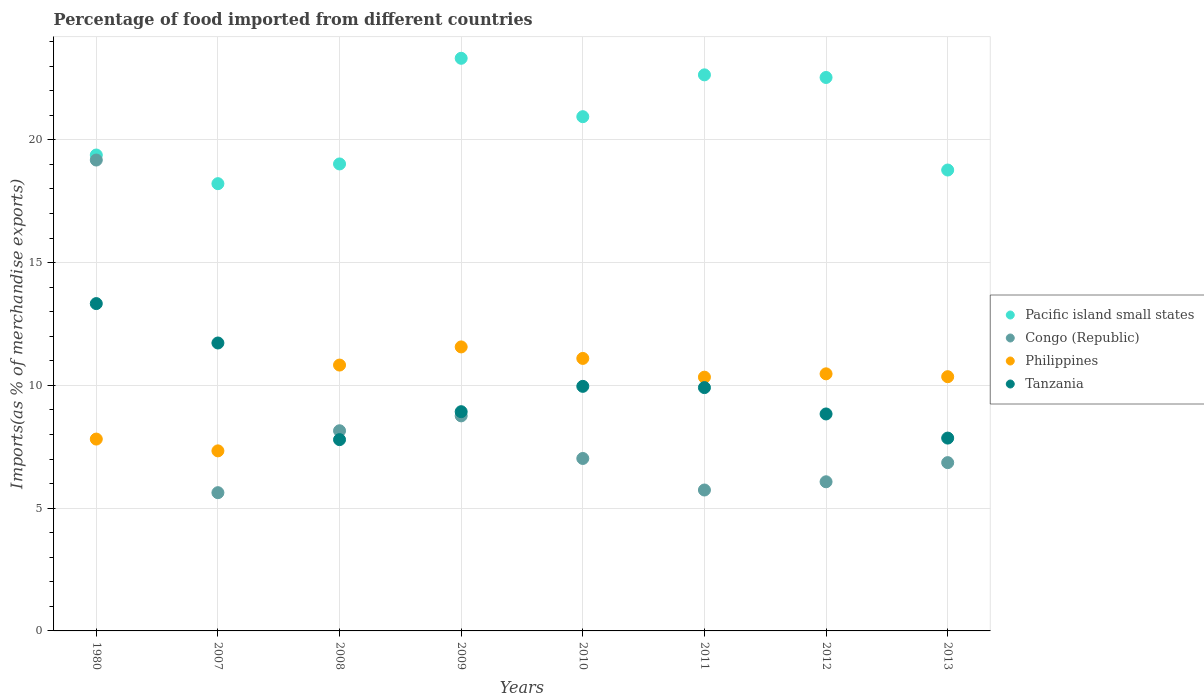How many different coloured dotlines are there?
Make the answer very short. 4. What is the percentage of imports to different countries in Congo (Republic) in 2010?
Make the answer very short. 7.02. Across all years, what is the maximum percentage of imports to different countries in Tanzania?
Ensure brevity in your answer.  13.33. Across all years, what is the minimum percentage of imports to different countries in Congo (Republic)?
Ensure brevity in your answer.  5.63. In which year was the percentage of imports to different countries in Congo (Republic) minimum?
Your response must be concise. 2007. What is the total percentage of imports to different countries in Congo (Republic) in the graph?
Provide a succinct answer. 67.41. What is the difference between the percentage of imports to different countries in Philippines in 2007 and that in 2013?
Your answer should be compact. -3.02. What is the difference between the percentage of imports to different countries in Philippines in 2009 and the percentage of imports to different countries in Tanzania in 2007?
Offer a terse response. -0.16. What is the average percentage of imports to different countries in Philippines per year?
Provide a short and direct response. 9.98. In the year 2013, what is the difference between the percentage of imports to different countries in Philippines and percentage of imports to different countries in Congo (Republic)?
Offer a terse response. 3.5. In how many years, is the percentage of imports to different countries in Tanzania greater than 16 %?
Your response must be concise. 0. What is the ratio of the percentage of imports to different countries in Pacific island small states in 2007 to that in 2011?
Make the answer very short. 0.8. Is the percentage of imports to different countries in Congo (Republic) in 2010 less than that in 2013?
Provide a short and direct response. No. Is the difference between the percentage of imports to different countries in Philippines in 2007 and 2013 greater than the difference between the percentage of imports to different countries in Congo (Republic) in 2007 and 2013?
Provide a short and direct response. No. What is the difference between the highest and the second highest percentage of imports to different countries in Philippines?
Your answer should be compact. 0.47. What is the difference between the highest and the lowest percentage of imports to different countries in Philippines?
Your answer should be very brief. 4.23. Is the percentage of imports to different countries in Pacific island small states strictly greater than the percentage of imports to different countries in Tanzania over the years?
Keep it short and to the point. Yes. How many dotlines are there?
Offer a very short reply. 4. Where does the legend appear in the graph?
Offer a terse response. Center right. How many legend labels are there?
Your answer should be very brief. 4. How are the legend labels stacked?
Provide a short and direct response. Vertical. What is the title of the graph?
Offer a terse response. Percentage of food imported from different countries. What is the label or title of the X-axis?
Your answer should be very brief. Years. What is the label or title of the Y-axis?
Make the answer very short. Imports(as % of merchandise exports). What is the Imports(as % of merchandise exports) in Pacific island small states in 1980?
Keep it short and to the point. 19.38. What is the Imports(as % of merchandise exports) of Congo (Republic) in 1980?
Your answer should be compact. 19.18. What is the Imports(as % of merchandise exports) in Philippines in 1980?
Keep it short and to the point. 7.81. What is the Imports(as % of merchandise exports) in Tanzania in 1980?
Make the answer very short. 13.33. What is the Imports(as % of merchandise exports) in Pacific island small states in 2007?
Provide a succinct answer. 18.22. What is the Imports(as % of merchandise exports) in Congo (Republic) in 2007?
Keep it short and to the point. 5.63. What is the Imports(as % of merchandise exports) of Philippines in 2007?
Provide a short and direct response. 7.33. What is the Imports(as % of merchandise exports) of Tanzania in 2007?
Provide a short and direct response. 11.73. What is the Imports(as % of merchandise exports) in Pacific island small states in 2008?
Ensure brevity in your answer.  19.02. What is the Imports(as % of merchandise exports) of Congo (Republic) in 2008?
Provide a succinct answer. 8.15. What is the Imports(as % of merchandise exports) of Philippines in 2008?
Ensure brevity in your answer.  10.83. What is the Imports(as % of merchandise exports) in Tanzania in 2008?
Keep it short and to the point. 7.79. What is the Imports(as % of merchandise exports) in Pacific island small states in 2009?
Your answer should be very brief. 23.32. What is the Imports(as % of merchandise exports) of Congo (Republic) in 2009?
Ensure brevity in your answer.  8.76. What is the Imports(as % of merchandise exports) of Philippines in 2009?
Offer a terse response. 11.57. What is the Imports(as % of merchandise exports) in Tanzania in 2009?
Provide a short and direct response. 8.93. What is the Imports(as % of merchandise exports) in Pacific island small states in 2010?
Your answer should be very brief. 20.94. What is the Imports(as % of merchandise exports) of Congo (Republic) in 2010?
Offer a very short reply. 7.02. What is the Imports(as % of merchandise exports) in Philippines in 2010?
Your response must be concise. 11.1. What is the Imports(as % of merchandise exports) of Tanzania in 2010?
Give a very brief answer. 9.96. What is the Imports(as % of merchandise exports) of Pacific island small states in 2011?
Provide a short and direct response. 22.65. What is the Imports(as % of merchandise exports) of Congo (Republic) in 2011?
Your response must be concise. 5.74. What is the Imports(as % of merchandise exports) of Philippines in 2011?
Make the answer very short. 10.33. What is the Imports(as % of merchandise exports) in Tanzania in 2011?
Keep it short and to the point. 9.91. What is the Imports(as % of merchandise exports) of Pacific island small states in 2012?
Your response must be concise. 22.54. What is the Imports(as % of merchandise exports) in Congo (Republic) in 2012?
Ensure brevity in your answer.  6.07. What is the Imports(as % of merchandise exports) in Philippines in 2012?
Your response must be concise. 10.47. What is the Imports(as % of merchandise exports) of Tanzania in 2012?
Your response must be concise. 8.84. What is the Imports(as % of merchandise exports) of Pacific island small states in 2013?
Give a very brief answer. 18.77. What is the Imports(as % of merchandise exports) of Congo (Republic) in 2013?
Ensure brevity in your answer.  6.85. What is the Imports(as % of merchandise exports) in Philippines in 2013?
Provide a succinct answer. 10.35. What is the Imports(as % of merchandise exports) of Tanzania in 2013?
Ensure brevity in your answer.  7.85. Across all years, what is the maximum Imports(as % of merchandise exports) in Pacific island small states?
Your answer should be very brief. 23.32. Across all years, what is the maximum Imports(as % of merchandise exports) of Congo (Republic)?
Your answer should be very brief. 19.18. Across all years, what is the maximum Imports(as % of merchandise exports) of Philippines?
Provide a succinct answer. 11.57. Across all years, what is the maximum Imports(as % of merchandise exports) of Tanzania?
Provide a short and direct response. 13.33. Across all years, what is the minimum Imports(as % of merchandise exports) in Pacific island small states?
Keep it short and to the point. 18.22. Across all years, what is the minimum Imports(as % of merchandise exports) of Congo (Republic)?
Give a very brief answer. 5.63. Across all years, what is the minimum Imports(as % of merchandise exports) of Philippines?
Your answer should be very brief. 7.33. Across all years, what is the minimum Imports(as % of merchandise exports) of Tanzania?
Keep it short and to the point. 7.79. What is the total Imports(as % of merchandise exports) in Pacific island small states in the graph?
Give a very brief answer. 164.84. What is the total Imports(as % of merchandise exports) in Congo (Republic) in the graph?
Give a very brief answer. 67.41. What is the total Imports(as % of merchandise exports) of Philippines in the graph?
Your response must be concise. 79.8. What is the total Imports(as % of merchandise exports) of Tanzania in the graph?
Provide a succinct answer. 78.34. What is the difference between the Imports(as % of merchandise exports) in Pacific island small states in 1980 and that in 2007?
Provide a short and direct response. 1.17. What is the difference between the Imports(as % of merchandise exports) in Congo (Republic) in 1980 and that in 2007?
Provide a short and direct response. 13.55. What is the difference between the Imports(as % of merchandise exports) of Philippines in 1980 and that in 2007?
Your answer should be compact. 0.48. What is the difference between the Imports(as % of merchandise exports) in Tanzania in 1980 and that in 2007?
Your answer should be compact. 1.6. What is the difference between the Imports(as % of merchandise exports) of Pacific island small states in 1980 and that in 2008?
Offer a terse response. 0.36. What is the difference between the Imports(as % of merchandise exports) of Congo (Republic) in 1980 and that in 2008?
Provide a short and direct response. 11.03. What is the difference between the Imports(as % of merchandise exports) in Philippines in 1980 and that in 2008?
Give a very brief answer. -3.01. What is the difference between the Imports(as % of merchandise exports) in Tanzania in 1980 and that in 2008?
Provide a succinct answer. 5.54. What is the difference between the Imports(as % of merchandise exports) in Pacific island small states in 1980 and that in 2009?
Your response must be concise. -3.94. What is the difference between the Imports(as % of merchandise exports) of Congo (Republic) in 1980 and that in 2009?
Ensure brevity in your answer.  10.42. What is the difference between the Imports(as % of merchandise exports) in Philippines in 1980 and that in 2009?
Ensure brevity in your answer.  -3.75. What is the difference between the Imports(as % of merchandise exports) in Tanzania in 1980 and that in 2009?
Offer a very short reply. 4.4. What is the difference between the Imports(as % of merchandise exports) of Pacific island small states in 1980 and that in 2010?
Provide a short and direct response. -1.56. What is the difference between the Imports(as % of merchandise exports) in Congo (Republic) in 1980 and that in 2010?
Your answer should be compact. 12.15. What is the difference between the Imports(as % of merchandise exports) in Philippines in 1980 and that in 2010?
Make the answer very short. -3.28. What is the difference between the Imports(as % of merchandise exports) in Tanzania in 1980 and that in 2010?
Make the answer very short. 3.37. What is the difference between the Imports(as % of merchandise exports) in Pacific island small states in 1980 and that in 2011?
Provide a succinct answer. -3.26. What is the difference between the Imports(as % of merchandise exports) in Congo (Republic) in 1980 and that in 2011?
Your answer should be very brief. 13.44. What is the difference between the Imports(as % of merchandise exports) of Philippines in 1980 and that in 2011?
Ensure brevity in your answer.  -2.52. What is the difference between the Imports(as % of merchandise exports) in Tanzania in 1980 and that in 2011?
Provide a short and direct response. 3.42. What is the difference between the Imports(as % of merchandise exports) of Pacific island small states in 1980 and that in 2012?
Provide a short and direct response. -3.16. What is the difference between the Imports(as % of merchandise exports) in Congo (Republic) in 1980 and that in 2012?
Offer a very short reply. 13.1. What is the difference between the Imports(as % of merchandise exports) of Philippines in 1980 and that in 2012?
Provide a succinct answer. -2.66. What is the difference between the Imports(as % of merchandise exports) of Tanzania in 1980 and that in 2012?
Ensure brevity in your answer.  4.49. What is the difference between the Imports(as % of merchandise exports) of Pacific island small states in 1980 and that in 2013?
Make the answer very short. 0.61. What is the difference between the Imports(as % of merchandise exports) in Congo (Republic) in 1980 and that in 2013?
Provide a short and direct response. 12.32. What is the difference between the Imports(as % of merchandise exports) of Philippines in 1980 and that in 2013?
Provide a succinct answer. -2.54. What is the difference between the Imports(as % of merchandise exports) of Tanzania in 1980 and that in 2013?
Provide a succinct answer. 5.48. What is the difference between the Imports(as % of merchandise exports) of Pacific island small states in 2007 and that in 2008?
Your response must be concise. -0.8. What is the difference between the Imports(as % of merchandise exports) of Congo (Republic) in 2007 and that in 2008?
Keep it short and to the point. -2.52. What is the difference between the Imports(as % of merchandise exports) in Philippines in 2007 and that in 2008?
Your answer should be compact. -3.49. What is the difference between the Imports(as % of merchandise exports) in Tanzania in 2007 and that in 2008?
Make the answer very short. 3.94. What is the difference between the Imports(as % of merchandise exports) in Pacific island small states in 2007 and that in 2009?
Make the answer very short. -5.11. What is the difference between the Imports(as % of merchandise exports) in Congo (Republic) in 2007 and that in 2009?
Provide a short and direct response. -3.13. What is the difference between the Imports(as % of merchandise exports) of Philippines in 2007 and that in 2009?
Provide a succinct answer. -4.23. What is the difference between the Imports(as % of merchandise exports) in Tanzania in 2007 and that in 2009?
Give a very brief answer. 2.8. What is the difference between the Imports(as % of merchandise exports) of Pacific island small states in 2007 and that in 2010?
Your answer should be compact. -2.73. What is the difference between the Imports(as % of merchandise exports) in Congo (Republic) in 2007 and that in 2010?
Offer a very short reply. -1.39. What is the difference between the Imports(as % of merchandise exports) of Philippines in 2007 and that in 2010?
Your response must be concise. -3.77. What is the difference between the Imports(as % of merchandise exports) of Tanzania in 2007 and that in 2010?
Keep it short and to the point. 1.77. What is the difference between the Imports(as % of merchandise exports) in Pacific island small states in 2007 and that in 2011?
Make the answer very short. -4.43. What is the difference between the Imports(as % of merchandise exports) of Congo (Republic) in 2007 and that in 2011?
Ensure brevity in your answer.  -0.11. What is the difference between the Imports(as % of merchandise exports) of Philippines in 2007 and that in 2011?
Your answer should be very brief. -3. What is the difference between the Imports(as % of merchandise exports) of Tanzania in 2007 and that in 2011?
Your answer should be very brief. 1.82. What is the difference between the Imports(as % of merchandise exports) in Pacific island small states in 2007 and that in 2012?
Offer a terse response. -4.33. What is the difference between the Imports(as % of merchandise exports) in Congo (Republic) in 2007 and that in 2012?
Offer a very short reply. -0.44. What is the difference between the Imports(as % of merchandise exports) of Philippines in 2007 and that in 2012?
Keep it short and to the point. -3.14. What is the difference between the Imports(as % of merchandise exports) of Tanzania in 2007 and that in 2012?
Provide a succinct answer. 2.89. What is the difference between the Imports(as % of merchandise exports) of Pacific island small states in 2007 and that in 2013?
Your response must be concise. -0.56. What is the difference between the Imports(as % of merchandise exports) in Congo (Republic) in 2007 and that in 2013?
Offer a terse response. -1.22. What is the difference between the Imports(as % of merchandise exports) of Philippines in 2007 and that in 2013?
Make the answer very short. -3.02. What is the difference between the Imports(as % of merchandise exports) in Tanzania in 2007 and that in 2013?
Provide a short and direct response. 3.87. What is the difference between the Imports(as % of merchandise exports) of Pacific island small states in 2008 and that in 2009?
Make the answer very short. -4.3. What is the difference between the Imports(as % of merchandise exports) of Congo (Republic) in 2008 and that in 2009?
Your answer should be compact. -0.61. What is the difference between the Imports(as % of merchandise exports) of Philippines in 2008 and that in 2009?
Your answer should be very brief. -0.74. What is the difference between the Imports(as % of merchandise exports) of Tanzania in 2008 and that in 2009?
Provide a succinct answer. -1.14. What is the difference between the Imports(as % of merchandise exports) of Pacific island small states in 2008 and that in 2010?
Provide a short and direct response. -1.92. What is the difference between the Imports(as % of merchandise exports) in Congo (Republic) in 2008 and that in 2010?
Ensure brevity in your answer.  1.13. What is the difference between the Imports(as % of merchandise exports) of Philippines in 2008 and that in 2010?
Offer a terse response. -0.27. What is the difference between the Imports(as % of merchandise exports) in Tanzania in 2008 and that in 2010?
Keep it short and to the point. -2.17. What is the difference between the Imports(as % of merchandise exports) of Pacific island small states in 2008 and that in 2011?
Offer a very short reply. -3.63. What is the difference between the Imports(as % of merchandise exports) of Congo (Republic) in 2008 and that in 2011?
Give a very brief answer. 2.41. What is the difference between the Imports(as % of merchandise exports) in Philippines in 2008 and that in 2011?
Your answer should be compact. 0.49. What is the difference between the Imports(as % of merchandise exports) in Tanzania in 2008 and that in 2011?
Offer a terse response. -2.12. What is the difference between the Imports(as % of merchandise exports) of Pacific island small states in 2008 and that in 2012?
Your answer should be very brief. -3.52. What is the difference between the Imports(as % of merchandise exports) of Congo (Republic) in 2008 and that in 2012?
Make the answer very short. 2.08. What is the difference between the Imports(as % of merchandise exports) of Philippines in 2008 and that in 2012?
Give a very brief answer. 0.36. What is the difference between the Imports(as % of merchandise exports) in Tanzania in 2008 and that in 2012?
Your answer should be compact. -1.05. What is the difference between the Imports(as % of merchandise exports) of Pacific island small states in 2008 and that in 2013?
Provide a succinct answer. 0.25. What is the difference between the Imports(as % of merchandise exports) in Congo (Republic) in 2008 and that in 2013?
Ensure brevity in your answer.  1.3. What is the difference between the Imports(as % of merchandise exports) of Philippines in 2008 and that in 2013?
Give a very brief answer. 0.47. What is the difference between the Imports(as % of merchandise exports) in Tanzania in 2008 and that in 2013?
Make the answer very short. -0.06. What is the difference between the Imports(as % of merchandise exports) in Pacific island small states in 2009 and that in 2010?
Provide a short and direct response. 2.38. What is the difference between the Imports(as % of merchandise exports) in Congo (Republic) in 2009 and that in 2010?
Your answer should be compact. 1.74. What is the difference between the Imports(as % of merchandise exports) of Philippines in 2009 and that in 2010?
Provide a short and direct response. 0.47. What is the difference between the Imports(as % of merchandise exports) of Tanzania in 2009 and that in 2010?
Provide a succinct answer. -1.03. What is the difference between the Imports(as % of merchandise exports) in Pacific island small states in 2009 and that in 2011?
Keep it short and to the point. 0.67. What is the difference between the Imports(as % of merchandise exports) of Congo (Republic) in 2009 and that in 2011?
Offer a very short reply. 3.02. What is the difference between the Imports(as % of merchandise exports) in Philippines in 2009 and that in 2011?
Your answer should be very brief. 1.23. What is the difference between the Imports(as % of merchandise exports) of Tanzania in 2009 and that in 2011?
Your answer should be compact. -0.98. What is the difference between the Imports(as % of merchandise exports) of Pacific island small states in 2009 and that in 2012?
Keep it short and to the point. 0.78. What is the difference between the Imports(as % of merchandise exports) of Congo (Republic) in 2009 and that in 2012?
Your answer should be compact. 2.68. What is the difference between the Imports(as % of merchandise exports) in Philippines in 2009 and that in 2012?
Give a very brief answer. 1.1. What is the difference between the Imports(as % of merchandise exports) in Tanzania in 2009 and that in 2012?
Keep it short and to the point. 0.09. What is the difference between the Imports(as % of merchandise exports) of Pacific island small states in 2009 and that in 2013?
Offer a terse response. 4.55. What is the difference between the Imports(as % of merchandise exports) of Congo (Republic) in 2009 and that in 2013?
Provide a succinct answer. 1.9. What is the difference between the Imports(as % of merchandise exports) in Philippines in 2009 and that in 2013?
Provide a short and direct response. 1.21. What is the difference between the Imports(as % of merchandise exports) of Tanzania in 2009 and that in 2013?
Your response must be concise. 1.08. What is the difference between the Imports(as % of merchandise exports) in Pacific island small states in 2010 and that in 2011?
Keep it short and to the point. -1.7. What is the difference between the Imports(as % of merchandise exports) of Congo (Republic) in 2010 and that in 2011?
Provide a short and direct response. 1.28. What is the difference between the Imports(as % of merchandise exports) of Philippines in 2010 and that in 2011?
Make the answer very short. 0.76. What is the difference between the Imports(as % of merchandise exports) of Tanzania in 2010 and that in 2011?
Your answer should be very brief. 0.05. What is the difference between the Imports(as % of merchandise exports) of Pacific island small states in 2010 and that in 2012?
Provide a succinct answer. -1.6. What is the difference between the Imports(as % of merchandise exports) in Congo (Republic) in 2010 and that in 2012?
Offer a terse response. 0.95. What is the difference between the Imports(as % of merchandise exports) in Philippines in 2010 and that in 2012?
Your answer should be compact. 0.63. What is the difference between the Imports(as % of merchandise exports) of Tanzania in 2010 and that in 2012?
Make the answer very short. 1.12. What is the difference between the Imports(as % of merchandise exports) in Pacific island small states in 2010 and that in 2013?
Your response must be concise. 2.17. What is the difference between the Imports(as % of merchandise exports) in Congo (Republic) in 2010 and that in 2013?
Ensure brevity in your answer.  0.17. What is the difference between the Imports(as % of merchandise exports) of Philippines in 2010 and that in 2013?
Ensure brevity in your answer.  0.74. What is the difference between the Imports(as % of merchandise exports) of Tanzania in 2010 and that in 2013?
Make the answer very short. 2.11. What is the difference between the Imports(as % of merchandise exports) in Pacific island small states in 2011 and that in 2012?
Make the answer very short. 0.11. What is the difference between the Imports(as % of merchandise exports) of Congo (Republic) in 2011 and that in 2012?
Make the answer very short. -0.34. What is the difference between the Imports(as % of merchandise exports) in Philippines in 2011 and that in 2012?
Your answer should be very brief. -0.14. What is the difference between the Imports(as % of merchandise exports) of Tanzania in 2011 and that in 2012?
Keep it short and to the point. 1.07. What is the difference between the Imports(as % of merchandise exports) of Pacific island small states in 2011 and that in 2013?
Ensure brevity in your answer.  3.88. What is the difference between the Imports(as % of merchandise exports) in Congo (Republic) in 2011 and that in 2013?
Your answer should be very brief. -1.11. What is the difference between the Imports(as % of merchandise exports) of Philippines in 2011 and that in 2013?
Ensure brevity in your answer.  -0.02. What is the difference between the Imports(as % of merchandise exports) in Tanzania in 2011 and that in 2013?
Provide a short and direct response. 2.06. What is the difference between the Imports(as % of merchandise exports) of Pacific island small states in 2012 and that in 2013?
Offer a very short reply. 3.77. What is the difference between the Imports(as % of merchandise exports) in Congo (Republic) in 2012 and that in 2013?
Your response must be concise. -0.78. What is the difference between the Imports(as % of merchandise exports) of Philippines in 2012 and that in 2013?
Offer a very short reply. 0.12. What is the difference between the Imports(as % of merchandise exports) of Tanzania in 2012 and that in 2013?
Your answer should be compact. 0.98. What is the difference between the Imports(as % of merchandise exports) of Pacific island small states in 1980 and the Imports(as % of merchandise exports) of Congo (Republic) in 2007?
Your answer should be compact. 13.75. What is the difference between the Imports(as % of merchandise exports) of Pacific island small states in 1980 and the Imports(as % of merchandise exports) of Philippines in 2007?
Make the answer very short. 12.05. What is the difference between the Imports(as % of merchandise exports) of Pacific island small states in 1980 and the Imports(as % of merchandise exports) of Tanzania in 2007?
Keep it short and to the point. 7.66. What is the difference between the Imports(as % of merchandise exports) of Congo (Republic) in 1980 and the Imports(as % of merchandise exports) of Philippines in 2007?
Give a very brief answer. 11.85. What is the difference between the Imports(as % of merchandise exports) of Congo (Republic) in 1980 and the Imports(as % of merchandise exports) of Tanzania in 2007?
Make the answer very short. 7.45. What is the difference between the Imports(as % of merchandise exports) of Philippines in 1980 and the Imports(as % of merchandise exports) of Tanzania in 2007?
Offer a terse response. -3.91. What is the difference between the Imports(as % of merchandise exports) of Pacific island small states in 1980 and the Imports(as % of merchandise exports) of Congo (Republic) in 2008?
Keep it short and to the point. 11.23. What is the difference between the Imports(as % of merchandise exports) of Pacific island small states in 1980 and the Imports(as % of merchandise exports) of Philippines in 2008?
Offer a very short reply. 8.56. What is the difference between the Imports(as % of merchandise exports) of Pacific island small states in 1980 and the Imports(as % of merchandise exports) of Tanzania in 2008?
Provide a short and direct response. 11.59. What is the difference between the Imports(as % of merchandise exports) of Congo (Republic) in 1980 and the Imports(as % of merchandise exports) of Philippines in 2008?
Provide a succinct answer. 8.35. What is the difference between the Imports(as % of merchandise exports) in Congo (Republic) in 1980 and the Imports(as % of merchandise exports) in Tanzania in 2008?
Keep it short and to the point. 11.39. What is the difference between the Imports(as % of merchandise exports) of Philippines in 1980 and the Imports(as % of merchandise exports) of Tanzania in 2008?
Your answer should be very brief. 0.02. What is the difference between the Imports(as % of merchandise exports) of Pacific island small states in 1980 and the Imports(as % of merchandise exports) of Congo (Republic) in 2009?
Provide a succinct answer. 10.62. What is the difference between the Imports(as % of merchandise exports) in Pacific island small states in 1980 and the Imports(as % of merchandise exports) in Philippines in 2009?
Make the answer very short. 7.82. What is the difference between the Imports(as % of merchandise exports) in Pacific island small states in 1980 and the Imports(as % of merchandise exports) in Tanzania in 2009?
Give a very brief answer. 10.45. What is the difference between the Imports(as % of merchandise exports) of Congo (Republic) in 1980 and the Imports(as % of merchandise exports) of Philippines in 2009?
Keep it short and to the point. 7.61. What is the difference between the Imports(as % of merchandise exports) in Congo (Republic) in 1980 and the Imports(as % of merchandise exports) in Tanzania in 2009?
Provide a short and direct response. 10.25. What is the difference between the Imports(as % of merchandise exports) in Philippines in 1980 and the Imports(as % of merchandise exports) in Tanzania in 2009?
Ensure brevity in your answer.  -1.12. What is the difference between the Imports(as % of merchandise exports) in Pacific island small states in 1980 and the Imports(as % of merchandise exports) in Congo (Republic) in 2010?
Keep it short and to the point. 12.36. What is the difference between the Imports(as % of merchandise exports) of Pacific island small states in 1980 and the Imports(as % of merchandise exports) of Philippines in 2010?
Give a very brief answer. 8.28. What is the difference between the Imports(as % of merchandise exports) in Pacific island small states in 1980 and the Imports(as % of merchandise exports) in Tanzania in 2010?
Provide a short and direct response. 9.42. What is the difference between the Imports(as % of merchandise exports) in Congo (Republic) in 1980 and the Imports(as % of merchandise exports) in Philippines in 2010?
Provide a short and direct response. 8.08. What is the difference between the Imports(as % of merchandise exports) in Congo (Republic) in 1980 and the Imports(as % of merchandise exports) in Tanzania in 2010?
Ensure brevity in your answer.  9.22. What is the difference between the Imports(as % of merchandise exports) in Philippines in 1980 and the Imports(as % of merchandise exports) in Tanzania in 2010?
Make the answer very short. -2.15. What is the difference between the Imports(as % of merchandise exports) of Pacific island small states in 1980 and the Imports(as % of merchandise exports) of Congo (Republic) in 2011?
Give a very brief answer. 13.64. What is the difference between the Imports(as % of merchandise exports) in Pacific island small states in 1980 and the Imports(as % of merchandise exports) in Philippines in 2011?
Keep it short and to the point. 9.05. What is the difference between the Imports(as % of merchandise exports) of Pacific island small states in 1980 and the Imports(as % of merchandise exports) of Tanzania in 2011?
Your answer should be very brief. 9.47. What is the difference between the Imports(as % of merchandise exports) of Congo (Republic) in 1980 and the Imports(as % of merchandise exports) of Philippines in 2011?
Provide a succinct answer. 8.84. What is the difference between the Imports(as % of merchandise exports) of Congo (Republic) in 1980 and the Imports(as % of merchandise exports) of Tanzania in 2011?
Provide a succinct answer. 9.27. What is the difference between the Imports(as % of merchandise exports) of Philippines in 1980 and the Imports(as % of merchandise exports) of Tanzania in 2011?
Your response must be concise. -2.1. What is the difference between the Imports(as % of merchandise exports) in Pacific island small states in 1980 and the Imports(as % of merchandise exports) in Congo (Republic) in 2012?
Provide a short and direct response. 13.31. What is the difference between the Imports(as % of merchandise exports) in Pacific island small states in 1980 and the Imports(as % of merchandise exports) in Philippines in 2012?
Make the answer very short. 8.91. What is the difference between the Imports(as % of merchandise exports) of Pacific island small states in 1980 and the Imports(as % of merchandise exports) of Tanzania in 2012?
Your answer should be compact. 10.55. What is the difference between the Imports(as % of merchandise exports) of Congo (Republic) in 1980 and the Imports(as % of merchandise exports) of Philippines in 2012?
Your response must be concise. 8.71. What is the difference between the Imports(as % of merchandise exports) in Congo (Republic) in 1980 and the Imports(as % of merchandise exports) in Tanzania in 2012?
Provide a short and direct response. 10.34. What is the difference between the Imports(as % of merchandise exports) of Philippines in 1980 and the Imports(as % of merchandise exports) of Tanzania in 2012?
Your answer should be very brief. -1.02. What is the difference between the Imports(as % of merchandise exports) of Pacific island small states in 1980 and the Imports(as % of merchandise exports) of Congo (Republic) in 2013?
Keep it short and to the point. 12.53. What is the difference between the Imports(as % of merchandise exports) in Pacific island small states in 1980 and the Imports(as % of merchandise exports) in Philippines in 2013?
Provide a short and direct response. 9.03. What is the difference between the Imports(as % of merchandise exports) in Pacific island small states in 1980 and the Imports(as % of merchandise exports) in Tanzania in 2013?
Your response must be concise. 11.53. What is the difference between the Imports(as % of merchandise exports) in Congo (Republic) in 1980 and the Imports(as % of merchandise exports) in Philippines in 2013?
Ensure brevity in your answer.  8.82. What is the difference between the Imports(as % of merchandise exports) of Congo (Republic) in 1980 and the Imports(as % of merchandise exports) of Tanzania in 2013?
Ensure brevity in your answer.  11.32. What is the difference between the Imports(as % of merchandise exports) in Philippines in 1980 and the Imports(as % of merchandise exports) in Tanzania in 2013?
Give a very brief answer. -0.04. What is the difference between the Imports(as % of merchandise exports) in Pacific island small states in 2007 and the Imports(as % of merchandise exports) in Congo (Republic) in 2008?
Keep it short and to the point. 10.06. What is the difference between the Imports(as % of merchandise exports) of Pacific island small states in 2007 and the Imports(as % of merchandise exports) of Philippines in 2008?
Provide a short and direct response. 7.39. What is the difference between the Imports(as % of merchandise exports) of Pacific island small states in 2007 and the Imports(as % of merchandise exports) of Tanzania in 2008?
Your answer should be compact. 10.43. What is the difference between the Imports(as % of merchandise exports) of Congo (Republic) in 2007 and the Imports(as % of merchandise exports) of Philippines in 2008?
Make the answer very short. -5.2. What is the difference between the Imports(as % of merchandise exports) in Congo (Republic) in 2007 and the Imports(as % of merchandise exports) in Tanzania in 2008?
Your response must be concise. -2.16. What is the difference between the Imports(as % of merchandise exports) of Philippines in 2007 and the Imports(as % of merchandise exports) of Tanzania in 2008?
Offer a terse response. -0.46. What is the difference between the Imports(as % of merchandise exports) in Pacific island small states in 2007 and the Imports(as % of merchandise exports) in Congo (Republic) in 2009?
Make the answer very short. 9.46. What is the difference between the Imports(as % of merchandise exports) in Pacific island small states in 2007 and the Imports(as % of merchandise exports) in Philippines in 2009?
Your response must be concise. 6.65. What is the difference between the Imports(as % of merchandise exports) in Pacific island small states in 2007 and the Imports(as % of merchandise exports) in Tanzania in 2009?
Ensure brevity in your answer.  9.29. What is the difference between the Imports(as % of merchandise exports) in Congo (Republic) in 2007 and the Imports(as % of merchandise exports) in Philippines in 2009?
Your response must be concise. -5.94. What is the difference between the Imports(as % of merchandise exports) in Congo (Republic) in 2007 and the Imports(as % of merchandise exports) in Tanzania in 2009?
Make the answer very short. -3.3. What is the difference between the Imports(as % of merchandise exports) in Philippines in 2007 and the Imports(as % of merchandise exports) in Tanzania in 2009?
Give a very brief answer. -1.6. What is the difference between the Imports(as % of merchandise exports) of Pacific island small states in 2007 and the Imports(as % of merchandise exports) of Congo (Republic) in 2010?
Provide a short and direct response. 11.19. What is the difference between the Imports(as % of merchandise exports) of Pacific island small states in 2007 and the Imports(as % of merchandise exports) of Philippines in 2010?
Give a very brief answer. 7.12. What is the difference between the Imports(as % of merchandise exports) in Pacific island small states in 2007 and the Imports(as % of merchandise exports) in Tanzania in 2010?
Ensure brevity in your answer.  8.25. What is the difference between the Imports(as % of merchandise exports) of Congo (Republic) in 2007 and the Imports(as % of merchandise exports) of Philippines in 2010?
Your answer should be compact. -5.47. What is the difference between the Imports(as % of merchandise exports) in Congo (Republic) in 2007 and the Imports(as % of merchandise exports) in Tanzania in 2010?
Your response must be concise. -4.33. What is the difference between the Imports(as % of merchandise exports) of Philippines in 2007 and the Imports(as % of merchandise exports) of Tanzania in 2010?
Provide a succinct answer. -2.63. What is the difference between the Imports(as % of merchandise exports) of Pacific island small states in 2007 and the Imports(as % of merchandise exports) of Congo (Republic) in 2011?
Your answer should be compact. 12.48. What is the difference between the Imports(as % of merchandise exports) of Pacific island small states in 2007 and the Imports(as % of merchandise exports) of Philippines in 2011?
Offer a terse response. 7.88. What is the difference between the Imports(as % of merchandise exports) in Pacific island small states in 2007 and the Imports(as % of merchandise exports) in Tanzania in 2011?
Ensure brevity in your answer.  8.31. What is the difference between the Imports(as % of merchandise exports) of Congo (Republic) in 2007 and the Imports(as % of merchandise exports) of Philippines in 2011?
Your answer should be compact. -4.7. What is the difference between the Imports(as % of merchandise exports) of Congo (Republic) in 2007 and the Imports(as % of merchandise exports) of Tanzania in 2011?
Offer a very short reply. -4.28. What is the difference between the Imports(as % of merchandise exports) in Philippines in 2007 and the Imports(as % of merchandise exports) in Tanzania in 2011?
Provide a short and direct response. -2.58. What is the difference between the Imports(as % of merchandise exports) in Pacific island small states in 2007 and the Imports(as % of merchandise exports) in Congo (Republic) in 2012?
Keep it short and to the point. 12.14. What is the difference between the Imports(as % of merchandise exports) in Pacific island small states in 2007 and the Imports(as % of merchandise exports) in Philippines in 2012?
Give a very brief answer. 7.75. What is the difference between the Imports(as % of merchandise exports) of Pacific island small states in 2007 and the Imports(as % of merchandise exports) of Tanzania in 2012?
Provide a succinct answer. 9.38. What is the difference between the Imports(as % of merchandise exports) of Congo (Republic) in 2007 and the Imports(as % of merchandise exports) of Philippines in 2012?
Give a very brief answer. -4.84. What is the difference between the Imports(as % of merchandise exports) of Congo (Republic) in 2007 and the Imports(as % of merchandise exports) of Tanzania in 2012?
Make the answer very short. -3.21. What is the difference between the Imports(as % of merchandise exports) of Philippines in 2007 and the Imports(as % of merchandise exports) of Tanzania in 2012?
Your response must be concise. -1.5. What is the difference between the Imports(as % of merchandise exports) in Pacific island small states in 2007 and the Imports(as % of merchandise exports) in Congo (Republic) in 2013?
Keep it short and to the point. 11.36. What is the difference between the Imports(as % of merchandise exports) in Pacific island small states in 2007 and the Imports(as % of merchandise exports) in Philippines in 2013?
Ensure brevity in your answer.  7.86. What is the difference between the Imports(as % of merchandise exports) of Pacific island small states in 2007 and the Imports(as % of merchandise exports) of Tanzania in 2013?
Ensure brevity in your answer.  10.36. What is the difference between the Imports(as % of merchandise exports) of Congo (Republic) in 2007 and the Imports(as % of merchandise exports) of Philippines in 2013?
Your response must be concise. -4.72. What is the difference between the Imports(as % of merchandise exports) in Congo (Republic) in 2007 and the Imports(as % of merchandise exports) in Tanzania in 2013?
Offer a very short reply. -2.22. What is the difference between the Imports(as % of merchandise exports) in Philippines in 2007 and the Imports(as % of merchandise exports) in Tanzania in 2013?
Ensure brevity in your answer.  -0.52. What is the difference between the Imports(as % of merchandise exports) of Pacific island small states in 2008 and the Imports(as % of merchandise exports) of Congo (Republic) in 2009?
Ensure brevity in your answer.  10.26. What is the difference between the Imports(as % of merchandise exports) in Pacific island small states in 2008 and the Imports(as % of merchandise exports) in Philippines in 2009?
Keep it short and to the point. 7.45. What is the difference between the Imports(as % of merchandise exports) in Pacific island small states in 2008 and the Imports(as % of merchandise exports) in Tanzania in 2009?
Your answer should be very brief. 10.09. What is the difference between the Imports(as % of merchandise exports) of Congo (Republic) in 2008 and the Imports(as % of merchandise exports) of Philippines in 2009?
Your answer should be compact. -3.41. What is the difference between the Imports(as % of merchandise exports) in Congo (Republic) in 2008 and the Imports(as % of merchandise exports) in Tanzania in 2009?
Ensure brevity in your answer.  -0.78. What is the difference between the Imports(as % of merchandise exports) of Philippines in 2008 and the Imports(as % of merchandise exports) of Tanzania in 2009?
Make the answer very short. 1.9. What is the difference between the Imports(as % of merchandise exports) of Pacific island small states in 2008 and the Imports(as % of merchandise exports) of Congo (Republic) in 2010?
Make the answer very short. 12. What is the difference between the Imports(as % of merchandise exports) of Pacific island small states in 2008 and the Imports(as % of merchandise exports) of Philippines in 2010?
Keep it short and to the point. 7.92. What is the difference between the Imports(as % of merchandise exports) of Pacific island small states in 2008 and the Imports(as % of merchandise exports) of Tanzania in 2010?
Give a very brief answer. 9.06. What is the difference between the Imports(as % of merchandise exports) in Congo (Republic) in 2008 and the Imports(as % of merchandise exports) in Philippines in 2010?
Make the answer very short. -2.95. What is the difference between the Imports(as % of merchandise exports) in Congo (Republic) in 2008 and the Imports(as % of merchandise exports) in Tanzania in 2010?
Provide a short and direct response. -1.81. What is the difference between the Imports(as % of merchandise exports) in Philippines in 2008 and the Imports(as % of merchandise exports) in Tanzania in 2010?
Your answer should be compact. 0.87. What is the difference between the Imports(as % of merchandise exports) in Pacific island small states in 2008 and the Imports(as % of merchandise exports) in Congo (Republic) in 2011?
Offer a very short reply. 13.28. What is the difference between the Imports(as % of merchandise exports) in Pacific island small states in 2008 and the Imports(as % of merchandise exports) in Philippines in 2011?
Your answer should be compact. 8.68. What is the difference between the Imports(as % of merchandise exports) in Pacific island small states in 2008 and the Imports(as % of merchandise exports) in Tanzania in 2011?
Keep it short and to the point. 9.11. What is the difference between the Imports(as % of merchandise exports) of Congo (Republic) in 2008 and the Imports(as % of merchandise exports) of Philippines in 2011?
Offer a very short reply. -2.18. What is the difference between the Imports(as % of merchandise exports) of Congo (Republic) in 2008 and the Imports(as % of merchandise exports) of Tanzania in 2011?
Keep it short and to the point. -1.76. What is the difference between the Imports(as % of merchandise exports) in Philippines in 2008 and the Imports(as % of merchandise exports) in Tanzania in 2011?
Offer a terse response. 0.92. What is the difference between the Imports(as % of merchandise exports) in Pacific island small states in 2008 and the Imports(as % of merchandise exports) in Congo (Republic) in 2012?
Ensure brevity in your answer.  12.94. What is the difference between the Imports(as % of merchandise exports) of Pacific island small states in 2008 and the Imports(as % of merchandise exports) of Philippines in 2012?
Offer a very short reply. 8.55. What is the difference between the Imports(as % of merchandise exports) in Pacific island small states in 2008 and the Imports(as % of merchandise exports) in Tanzania in 2012?
Provide a short and direct response. 10.18. What is the difference between the Imports(as % of merchandise exports) of Congo (Republic) in 2008 and the Imports(as % of merchandise exports) of Philippines in 2012?
Provide a succinct answer. -2.32. What is the difference between the Imports(as % of merchandise exports) in Congo (Republic) in 2008 and the Imports(as % of merchandise exports) in Tanzania in 2012?
Provide a short and direct response. -0.68. What is the difference between the Imports(as % of merchandise exports) of Philippines in 2008 and the Imports(as % of merchandise exports) of Tanzania in 2012?
Keep it short and to the point. 1.99. What is the difference between the Imports(as % of merchandise exports) in Pacific island small states in 2008 and the Imports(as % of merchandise exports) in Congo (Republic) in 2013?
Provide a succinct answer. 12.16. What is the difference between the Imports(as % of merchandise exports) of Pacific island small states in 2008 and the Imports(as % of merchandise exports) of Philippines in 2013?
Provide a short and direct response. 8.67. What is the difference between the Imports(as % of merchandise exports) in Pacific island small states in 2008 and the Imports(as % of merchandise exports) in Tanzania in 2013?
Offer a very short reply. 11.17. What is the difference between the Imports(as % of merchandise exports) of Congo (Republic) in 2008 and the Imports(as % of merchandise exports) of Philippines in 2013?
Ensure brevity in your answer.  -2.2. What is the difference between the Imports(as % of merchandise exports) in Congo (Republic) in 2008 and the Imports(as % of merchandise exports) in Tanzania in 2013?
Ensure brevity in your answer.  0.3. What is the difference between the Imports(as % of merchandise exports) in Philippines in 2008 and the Imports(as % of merchandise exports) in Tanzania in 2013?
Offer a terse response. 2.97. What is the difference between the Imports(as % of merchandise exports) of Pacific island small states in 2009 and the Imports(as % of merchandise exports) of Congo (Republic) in 2010?
Your response must be concise. 16.3. What is the difference between the Imports(as % of merchandise exports) of Pacific island small states in 2009 and the Imports(as % of merchandise exports) of Philippines in 2010?
Your response must be concise. 12.22. What is the difference between the Imports(as % of merchandise exports) in Pacific island small states in 2009 and the Imports(as % of merchandise exports) in Tanzania in 2010?
Offer a terse response. 13.36. What is the difference between the Imports(as % of merchandise exports) of Congo (Republic) in 2009 and the Imports(as % of merchandise exports) of Philippines in 2010?
Your answer should be very brief. -2.34. What is the difference between the Imports(as % of merchandise exports) in Congo (Republic) in 2009 and the Imports(as % of merchandise exports) in Tanzania in 2010?
Offer a very short reply. -1.2. What is the difference between the Imports(as % of merchandise exports) in Philippines in 2009 and the Imports(as % of merchandise exports) in Tanzania in 2010?
Make the answer very short. 1.61. What is the difference between the Imports(as % of merchandise exports) in Pacific island small states in 2009 and the Imports(as % of merchandise exports) in Congo (Republic) in 2011?
Your answer should be very brief. 17.58. What is the difference between the Imports(as % of merchandise exports) in Pacific island small states in 2009 and the Imports(as % of merchandise exports) in Philippines in 2011?
Keep it short and to the point. 12.99. What is the difference between the Imports(as % of merchandise exports) of Pacific island small states in 2009 and the Imports(as % of merchandise exports) of Tanzania in 2011?
Your answer should be very brief. 13.41. What is the difference between the Imports(as % of merchandise exports) of Congo (Republic) in 2009 and the Imports(as % of merchandise exports) of Philippines in 2011?
Provide a short and direct response. -1.58. What is the difference between the Imports(as % of merchandise exports) of Congo (Republic) in 2009 and the Imports(as % of merchandise exports) of Tanzania in 2011?
Your answer should be compact. -1.15. What is the difference between the Imports(as % of merchandise exports) in Philippines in 2009 and the Imports(as % of merchandise exports) in Tanzania in 2011?
Offer a very short reply. 1.66. What is the difference between the Imports(as % of merchandise exports) of Pacific island small states in 2009 and the Imports(as % of merchandise exports) of Congo (Republic) in 2012?
Your response must be concise. 17.25. What is the difference between the Imports(as % of merchandise exports) in Pacific island small states in 2009 and the Imports(as % of merchandise exports) in Philippines in 2012?
Make the answer very short. 12.85. What is the difference between the Imports(as % of merchandise exports) of Pacific island small states in 2009 and the Imports(as % of merchandise exports) of Tanzania in 2012?
Offer a very short reply. 14.49. What is the difference between the Imports(as % of merchandise exports) of Congo (Republic) in 2009 and the Imports(as % of merchandise exports) of Philippines in 2012?
Provide a short and direct response. -1.71. What is the difference between the Imports(as % of merchandise exports) of Congo (Republic) in 2009 and the Imports(as % of merchandise exports) of Tanzania in 2012?
Offer a very short reply. -0.08. What is the difference between the Imports(as % of merchandise exports) of Philippines in 2009 and the Imports(as % of merchandise exports) of Tanzania in 2012?
Make the answer very short. 2.73. What is the difference between the Imports(as % of merchandise exports) of Pacific island small states in 2009 and the Imports(as % of merchandise exports) of Congo (Republic) in 2013?
Offer a terse response. 16.47. What is the difference between the Imports(as % of merchandise exports) of Pacific island small states in 2009 and the Imports(as % of merchandise exports) of Philippines in 2013?
Your response must be concise. 12.97. What is the difference between the Imports(as % of merchandise exports) in Pacific island small states in 2009 and the Imports(as % of merchandise exports) in Tanzania in 2013?
Offer a very short reply. 15.47. What is the difference between the Imports(as % of merchandise exports) in Congo (Republic) in 2009 and the Imports(as % of merchandise exports) in Philippines in 2013?
Your response must be concise. -1.6. What is the difference between the Imports(as % of merchandise exports) in Congo (Republic) in 2009 and the Imports(as % of merchandise exports) in Tanzania in 2013?
Offer a terse response. 0.9. What is the difference between the Imports(as % of merchandise exports) in Philippines in 2009 and the Imports(as % of merchandise exports) in Tanzania in 2013?
Ensure brevity in your answer.  3.71. What is the difference between the Imports(as % of merchandise exports) of Pacific island small states in 2010 and the Imports(as % of merchandise exports) of Congo (Republic) in 2011?
Keep it short and to the point. 15.2. What is the difference between the Imports(as % of merchandise exports) of Pacific island small states in 2010 and the Imports(as % of merchandise exports) of Philippines in 2011?
Keep it short and to the point. 10.61. What is the difference between the Imports(as % of merchandise exports) of Pacific island small states in 2010 and the Imports(as % of merchandise exports) of Tanzania in 2011?
Provide a short and direct response. 11.03. What is the difference between the Imports(as % of merchandise exports) of Congo (Republic) in 2010 and the Imports(as % of merchandise exports) of Philippines in 2011?
Your answer should be compact. -3.31. What is the difference between the Imports(as % of merchandise exports) of Congo (Republic) in 2010 and the Imports(as % of merchandise exports) of Tanzania in 2011?
Your answer should be very brief. -2.89. What is the difference between the Imports(as % of merchandise exports) in Philippines in 2010 and the Imports(as % of merchandise exports) in Tanzania in 2011?
Make the answer very short. 1.19. What is the difference between the Imports(as % of merchandise exports) in Pacific island small states in 2010 and the Imports(as % of merchandise exports) in Congo (Republic) in 2012?
Your answer should be very brief. 14.87. What is the difference between the Imports(as % of merchandise exports) of Pacific island small states in 2010 and the Imports(as % of merchandise exports) of Philippines in 2012?
Provide a succinct answer. 10.47. What is the difference between the Imports(as % of merchandise exports) in Pacific island small states in 2010 and the Imports(as % of merchandise exports) in Tanzania in 2012?
Offer a very short reply. 12.11. What is the difference between the Imports(as % of merchandise exports) of Congo (Republic) in 2010 and the Imports(as % of merchandise exports) of Philippines in 2012?
Offer a terse response. -3.45. What is the difference between the Imports(as % of merchandise exports) of Congo (Republic) in 2010 and the Imports(as % of merchandise exports) of Tanzania in 2012?
Provide a short and direct response. -1.81. What is the difference between the Imports(as % of merchandise exports) of Philippines in 2010 and the Imports(as % of merchandise exports) of Tanzania in 2012?
Provide a short and direct response. 2.26. What is the difference between the Imports(as % of merchandise exports) of Pacific island small states in 2010 and the Imports(as % of merchandise exports) of Congo (Republic) in 2013?
Offer a terse response. 14.09. What is the difference between the Imports(as % of merchandise exports) in Pacific island small states in 2010 and the Imports(as % of merchandise exports) in Philippines in 2013?
Keep it short and to the point. 10.59. What is the difference between the Imports(as % of merchandise exports) of Pacific island small states in 2010 and the Imports(as % of merchandise exports) of Tanzania in 2013?
Provide a short and direct response. 13.09. What is the difference between the Imports(as % of merchandise exports) of Congo (Republic) in 2010 and the Imports(as % of merchandise exports) of Philippines in 2013?
Your response must be concise. -3.33. What is the difference between the Imports(as % of merchandise exports) of Congo (Republic) in 2010 and the Imports(as % of merchandise exports) of Tanzania in 2013?
Keep it short and to the point. -0.83. What is the difference between the Imports(as % of merchandise exports) of Philippines in 2010 and the Imports(as % of merchandise exports) of Tanzania in 2013?
Offer a terse response. 3.24. What is the difference between the Imports(as % of merchandise exports) of Pacific island small states in 2011 and the Imports(as % of merchandise exports) of Congo (Republic) in 2012?
Ensure brevity in your answer.  16.57. What is the difference between the Imports(as % of merchandise exports) of Pacific island small states in 2011 and the Imports(as % of merchandise exports) of Philippines in 2012?
Keep it short and to the point. 12.18. What is the difference between the Imports(as % of merchandise exports) in Pacific island small states in 2011 and the Imports(as % of merchandise exports) in Tanzania in 2012?
Your response must be concise. 13.81. What is the difference between the Imports(as % of merchandise exports) in Congo (Republic) in 2011 and the Imports(as % of merchandise exports) in Philippines in 2012?
Your answer should be compact. -4.73. What is the difference between the Imports(as % of merchandise exports) in Congo (Republic) in 2011 and the Imports(as % of merchandise exports) in Tanzania in 2012?
Your answer should be compact. -3.1. What is the difference between the Imports(as % of merchandise exports) in Philippines in 2011 and the Imports(as % of merchandise exports) in Tanzania in 2012?
Your response must be concise. 1.5. What is the difference between the Imports(as % of merchandise exports) in Pacific island small states in 2011 and the Imports(as % of merchandise exports) in Congo (Republic) in 2013?
Make the answer very short. 15.79. What is the difference between the Imports(as % of merchandise exports) of Pacific island small states in 2011 and the Imports(as % of merchandise exports) of Philippines in 2013?
Make the answer very short. 12.29. What is the difference between the Imports(as % of merchandise exports) of Pacific island small states in 2011 and the Imports(as % of merchandise exports) of Tanzania in 2013?
Provide a succinct answer. 14.79. What is the difference between the Imports(as % of merchandise exports) in Congo (Republic) in 2011 and the Imports(as % of merchandise exports) in Philippines in 2013?
Give a very brief answer. -4.62. What is the difference between the Imports(as % of merchandise exports) of Congo (Republic) in 2011 and the Imports(as % of merchandise exports) of Tanzania in 2013?
Make the answer very short. -2.11. What is the difference between the Imports(as % of merchandise exports) of Philippines in 2011 and the Imports(as % of merchandise exports) of Tanzania in 2013?
Provide a short and direct response. 2.48. What is the difference between the Imports(as % of merchandise exports) in Pacific island small states in 2012 and the Imports(as % of merchandise exports) in Congo (Republic) in 2013?
Make the answer very short. 15.69. What is the difference between the Imports(as % of merchandise exports) in Pacific island small states in 2012 and the Imports(as % of merchandise exports) in Philippines in 2013?
Keep it short and to the point. 12.19. What is the difference between the Imports(as % of merchandise exports) in Pacific island small states in 2012 and the Imports(as % of merchandise exports) in Tanzania in 2013?
Your answer should be compact. 14.69. What is the difference between the Imports(as % of merchandise exports) of Congo (Republic) in 2012 and the Imports(as % of merchandise exports) of Philippines in 2013?
Offer a very short reply. -4.28. What is the difference between the Imports(as % of merchandise exports) in Congo (Republic) in 2012 and the Imports(as % of merchandise exports) in Tanzania in 2013?
Offer a very short reply. -1.78. What is the difference between the Imports(as % of merchandise exports) in Philippines in 2012 and the Imports(as % of merchandise exports) in Tanzania in 2013?
Your response must be concise. 2.62. What is the average Imports(as % of merchandise exports) in Pacific island small states per year?
Offer a terse response. 20.61. What is the average Imports(as % of merchandise exports) of Congo (Republic) per year?
Provide a succinct answer. 8.43. What is the average Imports(as % of merchandise exports) in Philippines per year?
Offer a very short reply. 9.97. What is the average Imports(as % of merchandise exports) of Tanzania per year?
Give a very brief answer. 9.79. In the year 1980, what is the difference between the Imports(as % of merchandise exports) in Pacific island small states and Imports(as % of merchandise exports) in Congo (Republic)?
Offer a terse response. 0.2. In the year 1980, what is the difference between the Imports(as % of merchandise exports) of Pacific island small states and Imports(as % of merchandise exports) of Philippines?
Offer a terse response. 11.57. In the year 1980, what is the difference between the Imports(as % of merchandise exports) in Pacific island small states and Imports(as % of merchandise exports) in Tanzania?
Ensure brevity in your answer.  6.05. In the year 1980, what is the difference between the Imports(as % of merchandise exports) in Congo (Republic) and Imports(as % of merchandise exports) in Philippines?
Provide a succinct answer. 11.36. In the year 1980, what is the difference between the Imports(as % of merchandise exports) of Congo (Republic) and Imports(as % of merchandise exports) of Tanzania?
Give a very brief answer. 5.85. In the year 1980, what is the difference between the Imports(as % of merchandise exports) in Philippines and Imports(as % of merchandise exports) in Tanzania?
Ensure brevity in your answer.  -5.52. In the year 2007, what is the difference between the Imports(as % of merchandise exports) of Pacific island small states and Imports(as % of merchandise exports) of Congo (Republic)?
Offer a terse response. 12.59. In the year 2007, what is the difference between the Imports(as % of merchandise exports) in Pacific island small states and Imports(as % of merchandise exports) in Philippines?
Offer a terse response. 10.88. In the year 2007, what is the difference between the Imports(as % of merchandise exports) in Pacific island small states and Imports(as % of merchandise exports) in Tanzania?
Provide a short and direct response. 6.49. In the year 2007, what is the difference between the Imports(as % of merchandise exports) in Congo (Republic) and Imports(as % of merchandise exports) in Philippines?
Give a very brief answer. -1.7. In the year 2007, what is the difference between the Imports(as % of merchandise exports) of Congo (Republic) and Imports(as % of merchandise exports) of Tanzania?
Your answer should be compact. -6.1. In the year 2007, what is the difference between the Imports(as % of merchandise exports) of Philippines and Imports(as % of merchandise exports) of Tanzania?
Ensure brevity in your answer.  -4.39. In the year 2008, what is the difference between the Imports(as % of merchandise exports) in Pacific island small states and Imports(as % of merchandise exports) in Congo (Republic)?
Provide a short and direct response. 10.87. In the year 2008, what is the difference between the Imports(as % of merchandise exports) of Pacific island small states and Imports(as % of merchandise exports) of Philippines?
Your answer should be very brief. 8.19. In the year 2008, what is the difference between the Imports(as % of merchandise exports) in Pacific island small states and Imports(as % of merchandise exports) in Tanzania?
Provide a succinct answer. 11.23. In the year 2008, what is the difference between the Imports(as % of merchandise exports) in Congo (Republic) and Imports(as % of merchandise exports) in Philippines?
Offer a terse response. -2.68. In the year 2008, what is the difference between the Imports(as % of merchandise exports) in Congo (Republic) and Imports(as % of merchandise exports) in Tanzania?
Offer a very short reply. 0.36. In the year 2008, what is the difference between the Imports(as % of merchandise exports) of Philippines and Imports(as % of merchandise exports) of Tanzania?
Ensure brevity in your answer.  3.04. In the year 2009, what is the difference between the Imports(as % of merchandise exports) of Pacific island small states and Imports(as % of merchandise exports) of Congo (Republic)?
Give a very brief answer. 14.56. In the year 2009, what is the difference between the Imports(as % of merchandise exports) of Pacific island small states and Imports(as % of merchandise exports) of Philippines?
Your answer should be compact. 11.76. In the year 2009, what is the difference between the Imports(as % of merchandise exports) in Pacific island small states and Imports(as % of merchandise exports) in Tanzania?
Provide a short and direct response. 14.39. In the year 2009, what is the difference between the Imports(as % of merchandise exports) of Congo (Republic) and Imports(as % of merchandise exports) of Philippines?
Your answer should be compact. -2.81. In the year 2009, what is the difference between the Imports(as % of merchandise exports) of Congo (Republic) and Imports(as % of merchandise exports) of Tanzania?
Your response must be concise. -0.17. In the year 2009, what is the difference between the Imports(as % of merchandise exports) of Philippines and Imports(as % of merchandise exports) of Tanzania?
Offer a very short reply. 2.64. In the year 2010, what is the difference between the Imports(as % of merchandise exports) in Pacific island small states and Imports(as % of merchandise exports) in Congo (Republic)?
Your answer should be compact. 13.92. In the year 2010, what is the difference between the Imports(as % of merchandise exports) in Pacific island small states and Imports(as % of merchandise exports) in Philippines?
Offer a terse response. 9.85. In the year 2010, what is the difference between the Imports(as % of merchandise exports) of Pacific island small states and Imports(as % of merchandise exports) of Tanzania?
Your answer should be compact. 10.98. In the year 2010, what is the difference between the Imports(as % of merchandise exports) of Congo (Republic) and Imports(as % of merchandise exports) of Philippines?
Give a very brief answer. -4.07. In the year 2010, what is the difference between the Imports(as % of merchandise exports) in Congo (Republic) and Imports(as % of merchandise exports) in Tanzania?
Keep it short and to the point. -2.94. In the year 2010, what is the difference between the Imports(as % of merchandise exports) of Philippines and Imports(as % of merchandise exports) of Tanzania?
Offer a terse response. 1.14. In the year 2011, what is the difference between the Imports(as % of merchandise exports) of Pacific island small states and Imports(as % of merchandise exports) of Congo (Republic)?
Offer a terse response. 16.91. In the year 2011, what is the difference between the Imports(as % of merchandise exports) of Pacific island small states and Imports(as % of merchandise exports) of Philippines?
Your answer should be compact. 12.31. In the year 2011, what is the difference between the Imports(as % of merchandise exports) in Pacific island small states and Imports(as % of merchandise exports) in Tanzania?
Ensure brevity in your answer.  12.74. In the year 2011, what is the difference between the Imports(as % of merchandise exports) of Congo (Republic) and Imports(as % of merchandise exports) of Philippines?
Your response must be concise. -4.6. In the year 2011, what is the difference between the Imports(as % of merchandise exports) of Congo (Republic) and Imports(as % of merchandise exports) of Tanzania?
Offer a very short reply. -4.17. In the year 2011, what is the difference between the Imports(as % of merchandise exports) of Philippines and Imports(as % of merchandise exports) of Tanzania?
Provide a succinct answer. 0.43. In the year 2012, what is the difference between the Imports(as % of merchandise exports) of Pacific island small states and Imports(as % of merchandise exports) of Congo (Republic)?
Offer a very short reply. 16.47. In the year 2012, what is the difference between the Imports(as % of merchandise exports) of Pacific island small states and Imports(as % of merchandise exports) of Philippines?
Offer a very short reply. 12.07. In the year 2012, what is the difference between the Imports(as % of merchandise exports) in Pacific island small states and Imports(as % of merchandise exports) in Tanzania?
Offer a terse response. 13.7. In the year 2012, what is the difference between the Imports(as % of merchandise exports) in Congo (Republic) and Imports(as % of merchandise exports) in Philippines?
Provide a short and direct response. -4.4. In the year 2012, what is the difference between the Imports(as % of merchandise exports) of Congo (Republic) and Imports(as % of merchandise exports) of Tanzania?
Your response must be concise. -2.76. In the year 2012, what is the difference between the Imports(as % of merchandise exports) in Philippines and Imports(as % of merchandise exports) in Tanzania?
Your answer should be compact. 1.63. In the year 2013, what is the difference between the Imports(as % of merchandise exports) in Pacific island small states and Imports(as % of merchandise exports) in Congo (Republic)?
Offer a very short reply. 11.92. In the year 2013, what is the difference between the Imports(as % of merchandise exports) of Pacific island small states and Imports(as % of merchandise exports) of Philippines?
Offer a very short reply. 8.42. In the year 2013, what is the difference between the Imports(as % of merchandise exports) of Pacific island small states and Imports(as % of merchandise exports) of Tanzania?
Make the answer very short. 10.92. In the year 2013, what is the difference between the Imports(as % of merchandise exports) of Congo (Republic) and Imports(as % of merchandise exports) of Tanzania?
Give a very brief answer. -1. In the year 2013, what is the difference between the Imports(as % of merchandise exports) of Philippines and Imports(as % of merchandise exports) of Tanzania?
Make the answer very short. 2.5. What is the ratio of the Imports(as % of merchandise exports) in Pacific island small states in 1980 to that in 2007?
Your answer should be compact. 1.06. What is the ratio of the Imports(as % of merchandise exports) in Congo (Republic) in 1980 to that in 2007?
Offer a terse response. 3.41. What is the ratio of the Imports(as % of merchandise exports) of Philippines in 1980 to that in 2007?
Ensure brevity in your answer.  1.07. What is the ratio of the Imports(as % of merchandise exports) of Tanzania in 1980 to that in 2007?
Your answer should be compact. 1.14. What is the ratio of the Imports(as % of merchandise exports) of Pacific island small states in 1980 to that in 2008?
Offer a very short reply. 1.02. What is the ratio of the Imports(as % of merchandise exports) in Congo (Republic) in 1980 to that in 2008?
Your answer should be compact. 2.35. What is the ratio of the Imports(as % of merchandise exports) in Philippines in 1980 to that in 2008?
Provide a succinct answer. 0.72. What is the ratio of the Imports(as % of merchandise exports) in Tanzania in 1980 to that in 2008?
Your answer should be very brief. 1.71. What is the ratio of the Imports(as % of merchandise exports) of Pacific island small states in 1980 to that in 2009?
Give a very brief answer. 0.83. What is the ratio of the Imports(as % of merchandise exports) of Congo (Republic) in 1980 to that in 2009?
Keep it short and to the point. 2.19. What is the ratio of the Imports(as % of merchandise exports) of Philippines in 1980 to that in 2009?
Provide a short and direct response. 0.68. What is the ratio of the Imports(as % of merchandise exports) in Tanzania in 1980 to that in 2009?
Offer a terse response. 1.49. What is the ratio of the Imports(as % of merchandise exports) in Pacific island small states in 1980 to that in 2010?
Offer a terse response. 0.93. What is the ratio of the Imports(as % of merchandise exports) of Congo (Republic) in 1980 to that in 2010?
Your response must be concise. 2.73. What is the ratio of the Imports(as % of merchandise exports) in Philippines in 1980 to that in 2010?
Your answer should be very brief. 0.7. What is the ratio of the Imports(as % of merchandise exports) of Tanzania in 1980 to that in 2010?
Offer a terse response. 1.34. What is the ratio of the Imports(as % of merchandise exports) of Pacific island small states in 1980 to that in 2011?
Your response must be concise. 0.86. What is the ratio of the Imports(as % of merchandise exports) in Congo (Republic) in 1980 to that in 2011?
Provide a short and direct response. 3.34. What is the ratio of the Imports(as % of merchandise exports) of Philippines in 1980 to that in 2011?
Ensure brevity in your answer.  0.76. What is the ratio of the Imports(as % of merchandise exports) of Tanzania in 1980 to that in 2011?
Offer a very short reply. 1.35. What is the ratio of the Imports(as % of merchandise exports) of Pacific island small states in 1980 to that in 2012?
Offer a terse response. 0.86. What is the ratio of the Imports(as % of merchandise exports) in Congo (Republic) in 1980 to that in 2012?
Ensure brevity in your answer.  3.16. What is the ratio of the Imports(as % of merchandise exports) of Philippines in 1980 to that in 2012?
Your answer should be compact. 0.75. What is the ratio of the Imports(as % of merchandise exports) of Tanzania in 1980 to that in 2012?
Offer a terse response. 1.51. What is the ratio of the Imports(as % of merchandise exports) of Pacific island small states in 1980 to that in 2013?
Your response must be concise. 1.03. What is the ratio of the Imports(as % of merchandise exports) in Congo (Republic) in 1980 to that in 2013?
Your answer should be very brief. 2.8. What is the ratio of the Imports(as % of merchandise exports) in Philippines in 1980 to that in 2013?
Ensure brevity in your answer.  0.75. What is the ratio of the Imports(as % of merchandise exports) in Tanzania in 1980 to that in 2013?
Offer a terse response. 1.7. What is the ratio of the Imports(as % of merchandise exports) of Pacific island small states in 2007 to that in 2008?
Provide a succinct answer. 0.96. What is the ratio of the Imports(as % of merchandise exports) of Congo (Republic) in 2007 to that in 2008?
Ensure brevity in your answer.  0.69. What is the ratio of the Imports(as % of merchandise exports) in Philippines in 2007 to that in 2008?
Offer a very short reply. 0.68. What is the ratio of the Imports(as % of merchandise exports) of Tanzania in 2007 to that in 2008?
Keep it short and to the point. 1.51. What is the ratio of the Imports(as % of merchandise exports) in Pacific island small states in 2007 to that in 2009?
Provide a succinct answer. 0.78. What is the ratio of the Imports(as % of merchandise exports) of Congo (Republic) in 2007 to that in 2009?
Your answer should be compact. 0.64. What is the ratio of the Imports(as % of merchandise exports) in Philippines in 2007 to that in 2009?
Your answer should be compact. 0.63. What is the ratio of the Imports(as % of merchandise exports) in Tanzania in 2007 to that in 2009?
Provide a short and direct response. 1.31. What is the ratio of the Imports(as % of merchandise exports) in Pacific island small states in 2007 to that in 2010?
Your answer should be very brief. 0.87. What is the ratio of the Imports(as % of merchandise exports) of Congo (Republic) in 2007 to that in 2010?
Provide a short and direct response. 0.8. What is the ratio of the Imports(as % of merchandise exports) in Philippines in 2007 to that in 2010?
Ensure brevity in your answer.  0.66. What is the ratio of the Imports(as % of merchandise exports) of Tanzania in 2007 to that in 2010?
Your answer should be very brief. 1.18. What is the ratio of the Imports(as % of merchandise exports) in Pacific island small states in 2007 to that in 2011?
Make the answer very short. 0.8. What is the ratio of the Imports(as % of merchandise exports) of Congo (Republic) in 2007 to that in 2011?
Offer a very short reply. 0.98. What is the ratio of the Imports(as % of merchandise exports) of Philippines in 2007 to that in 2011?
Your answer should be compact. 0.71. What is the ratio of the Imports(as % of merchandise exports) in Tanzania in 2007 to that in 2011?
Ensure brevity in your answer.  1.18. What is the ratio of the Imports(as % of merchandise exports) of Pacific island small states in 2007 to that in 2012?
Keep it short and to the point. 0.81. What is the ratio of the Imports(as % of merchandise exports) of Congo (Republic) in 2007 to that in 2012?
Your answer should be very brief. 0.93. What is the ratio of the Imports(as % of merchandise exports) in Philippines in 2007 to that in 2012?
Your answer should be very brief. 0.7. What is the ratio of the Imports(as % of merchandise exports) of Tanzania in 2007 to that in 2012?
Provide a succinct answer. 1.33. What is the ratio of the Imports(as % of merchandise exports) in Pacific island small states in 2007 to that in 2013?
Your answer should be very brief. 0.97. What is the ratio of the Imports(as % of merchandise exports) of Congo (Republic) in 2007 to that in 2013?
Make the answer very short. 0.82. What is the ratio of the Imports(as % of merchandise exports) of Philippines in 2007 to that in 2013?
Make the answer very short. 0.71. What is the ratio of the Imports(as % of merchandise exports) in Tanzania in 2007 to that in 2013?
Make the answer very short. 1.49. What is the ratio of the Imports(as % of merchandise exports) of Pacific island small states in 2008 to that in 2009?
Your answer should be very brief. 0.82. What is the ratio of the Imports(as % of merchandise exports) of Congo (Republic) in 2008 to that in 2009?
Keep it short and to the point. 0.93. What is the ratio of the Imports(as % of merchandise exports) in Philippines in 2008 to that in 2009?
Offer a very short reply. 0.94. What is the ratio of the Imports(as % of merchandise exports) in Tanzania in 2008 to that in 2009?
Ensure brevity in your answer.  0.87. What is the ratio of the Imports(as % of merchandise exports) of Pacific island small states in 2008 to that in 2010?
Keep it short and to the point. 0.91. What is the ratio of the Imports(as % of merchandise exports) in Congo (Republic) in 2008 to that in 2010?
Keep it short and to the point. 1.16. What is the ratio of the Imports(as % of merchandise exports) of Philippines in 2008 to that in 2010?
Give a very brief answer. 0.98. What is the ratio of the Imports(as % of merchandise exports) of Tanzania in 2008 to that in 2010?
Your answer should be very brief. 0.78. What is the ratio of the Imports(as % of merchandise exports) of Pacific island small states in 2008 to that in 2011?
Offer a very short reply. 0.84. What is the ratio of the Imports(as % of merchandise exports) in Congo (Republic) in 2008 to that in 2011?
Make the answer very short. 1.42. What is the ratio of the Imports(as % of merchandise exports) of Philippines in 2008 to that in 2011?
Offer a terse response. 1.05. What is the ratio of the Imports(as % of merchandise exports) in Tanzania in 2008 to that in 2011?
Your answer should be very brief. 0.79. What is the ratio of the Imports(as % of merchandise exports) in Pacific island small states in 2008 to that in 2012?
Offer a terse response. 0.84. What is the ratio of the Imports(as % of merchandise exports) in Congo (Republic) in 2008 to that in 2012?
Provide a short and direct response. 1.34. What is the ratio of the Imports(as % of merchandise exports) in Philippines in 2008 to that in 2012?
Give a very brief answer. 1.03. What is the ratio of the Imports(as % of merchandise exports) in Tanzania in 2008 to that in 2012?
Give a very brief answer. 0.88. What is the ratio of the Imports(as % of merchandise exports) in Pacific island small states in 2008 to that in 2013?
Ensure brevity in your answer.  1.01. What is the ratio of the Imports(as % of merchandise exports) in Congo (Republic) in 2008 to that in 2013?
Your answer should be very brief. 1.19. What is the ratio of the Imports(as % of merchandise exports) in Philippines in 2008 to that in 2013?
Give a very brief answer. 1.05. What is the ratio of the Imports(as % of merchandise exports) of Pacific island small states in 2009 to that in 2010?
Your answer should be compact. 1.11. What is the ratio of the Imports(as % of merchandise exports) in Congo (Republic) in 2009 to that in 2010?
Provide a short and direct response. 1.25. What is the ratio of the Imports(as % of merchandise exports) of Philippines in 2009 to that in 2010?
Offer a very short reply. 1.04. What is the ratio of the Imports(as % of merchandise exports) in Tanzania in 2009 to that in 2010?
Give a very brief answer. 0.9. What is the ratio of the Imports(as % of merchandise exports) in Pacific island small states in 2009 to that in 2011?
Your answer should be very brief. 1.03. What is the ratio of the Imports(as % of merchandise exports) of Congo (Republic) in 2009 to that in 2011?
Your answer should be very brief. 1.53. What is the ratio of the Imports(as % of merchandise exports) of Philippines in 2009 to that in 2011?
Offer a terse response. 1.12. What is the ratio of the Imports(as % of merchandise exports) of Tanzania in 2009 to that in 2011?
Keep it short and to the point. 0.9. What is the ratio of the Imports(as % of merchandise exports) of Pacific island small states in 2009 to that in 2012?
Provide a short and direct response. 1.03. What is the ratio of the Imports(as % of merchandise exports) in Congo (Republic) in 2009 to that in 2012?
Ensure brevity in your answer.  1.44. What is the ratio of the Imports(as % of merchandise exports) of Philippines in 2009 to that in 2012?
Make the answer very short. 1.1. What is the ratio of the Imports(as % of merchandise exports) of Tanzania in 2009 to that in 2012?
Keep it short and to the point. 1.01. What is the ratio of the Imports(as % of merchandise exports) in Pacific island small states in 2009 to that in 2013?
Provide a short and direct response. 1.24. What is the ratio of the Imports(as % of merchandise exports) of Congo (Republic) in 2009 to that in 2013?
Provide a succinct answer. 1.28. What is the ratio of the Imports(as % of merchandise exports) in Philippines in 2009 to that in 2013?
Your answer should be very brief. 1.12. What is the ratio of the Imports(as % of merchandise exports) in Tanzania in 2009 to that in 2013?
Provide a succinct answer. 1.14. What is the ratio of the Imports(as % of merchandise exports) in Pacific island small states in 2010 to that in 2011?
Provide a succinct answer. 0.92. What is the ratio of the Imports(as % of merchandise exports) of Congo (Republic) in 2010 to that in 2011?
Provide a short and direct response. 1.22. What is the ratio of the Imports(as % of merchandise exports) in Philippines in 2010 to that in 2011?
Provide a succinct answer. 1.07. What is the ratio of the Imports(as % of merchandise exports) in Pacific island small states in 2010 to that in 2012?
Ensure brevity in your answer.  0.93. What is the ratio of the Imports(as % of merchandise exports) of Congo (Republic) in 2010 to that in 2012?
Offer a very short reply. 1.16. What is the ratio of the Imports(as % of merchandise exports) in Philippines in 2010 to that in 2012?
Make the answer very short. 1.06. What is the ratio of the Imports(as % of merchandise exports) in Tanzania in 2010 to that in 2012?
Keep it short and to the point. 1.13. What is the ratio of the Imports(as % of merchandise exports) in Pacific island small states in 2010 to that in 2013?
Offer a very short reply. 1.12. What is the ratio of the Imports(as % of merchandise exports) of Congo (Republic) in 2010 to that in 2013?
Provide a short and direct response. 1.02. What is the ratio of the Imports(as % of merchandise exports) in Philippines in 2010 to that in 2013?
Keep it short and to the point. 1.07. What is the ratio of the Imports(as % of merchandise exports) in Tanzania in 2010 to that in 2013?
Keep it short and to the point. 1.27. What is the ratio of the Imports(as % of merchandise exports) in Pacific island small states in 2011 to that in 2012?
Provide a short and direct response. 1. What is the ratio of the Imports(as % of merchandise exports) of Congo (Republic) in 2011 to that in 2012?
Keep it short and to the point. 0.94. What is the ratio of the Imports(as % of merchandise exports) of Tanzania in 2011 to that in 2012?
Provide a succinct answer. 1.12. What is the ratio of the Imports(as % of merchandise exports) of Pacific island small states in 2011 to that in 2013?
Give a very brief answer. 1.21. What is the ratio of the Imports(as % of merchandise exports) of Congo (Republic) in 2011 to that in 2013?
Your answer should be compact. 0.84. What is the ratio of the Imports(as % of merchandise exports) in Tanzania in 2011 to that in 2013?
Your answer should be very brief. 1.26. What is the ratio of the Imports(as % of merchandise exports) in Pacific island small states in 2012 to that in 2013?
Offer a terse response. 1.2. What is the ratio of the Imports(as % of merchandise exports) of Congo (Republic) in 2012 to that in 2013?
Make the answer very short. 0.89. What is the ratio of the Imports(as % of merchandise exports) of Philippines in 2012 to that in 2013?
Offer a very short reply. 1.01. What is the ratio of the Imports(as % of merchandise exports) of Tanzania in 2012 to that in 2013?
Make the answer very short. 1.13. What is the difference between the highest and the second highest Imports(as % of merchandise exports) in Pacific island small states?
Make the answer very short. 0.67. What is the difference between the highest and the second highest Imports(as % of merchandise exports) in Congo (Republic)?
Your answer should be compact. 10.42. What is the difference between the highest and the second highest Imports(as % of merchandise exports) in Philippines?
Ensure brevity in your answer.  0.47. What is the difference between the highest and the second highest Imports(as % of merchandise exports) in Tanzania?
Provide a succinct answer. 1.6. What is the difference between the highest and the lowest Imports(as % of merchandise exports) in Pacific island small states?
Keep it short and to the point. 5.11. What is the difference between the highest and the lowest Imports(as % of merchandise exports) of Congo (Republic)?
Make the answer very short. 13.55. What is the difference between the highest and the lowest Imports(as % of merchandise exports) of Philippines?
Provide a short and direct response. 4.23. What is the difference between the highest and the lowest Imports(as % of merchandise exports) of Tanzania?
Offer a very short reply. 5.54. 